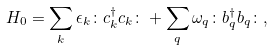<formula> <loc_0><loc_0><loc_500><loc_500>H _ { 0 } = \sum _ { k } \epsilon _ { k } \colon c ^ { \dagger } _ { k } c _ { k } \colon + \sum _ { q } \omega _ { q } \colon b ^ { \dagger } _ { q } b _ { q } \colon ,</formula> 